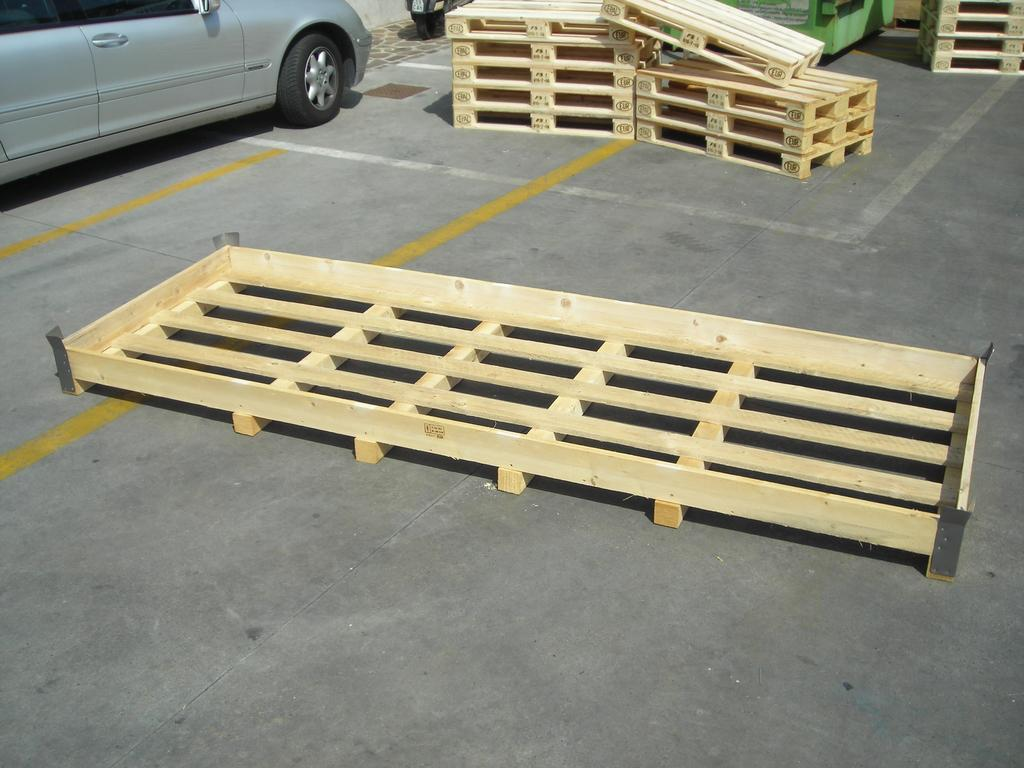What type of view is shown in the image? The image is an outside view. What can be seen on the road in the image? There are wooden objects placed on the road. What vehicles are visible in the top left of the image? There is a car and a bike in the top left of the image. How many friends are shown taking a voyage with the goldfish in the image? There are no friends or goldfish present in the image. 